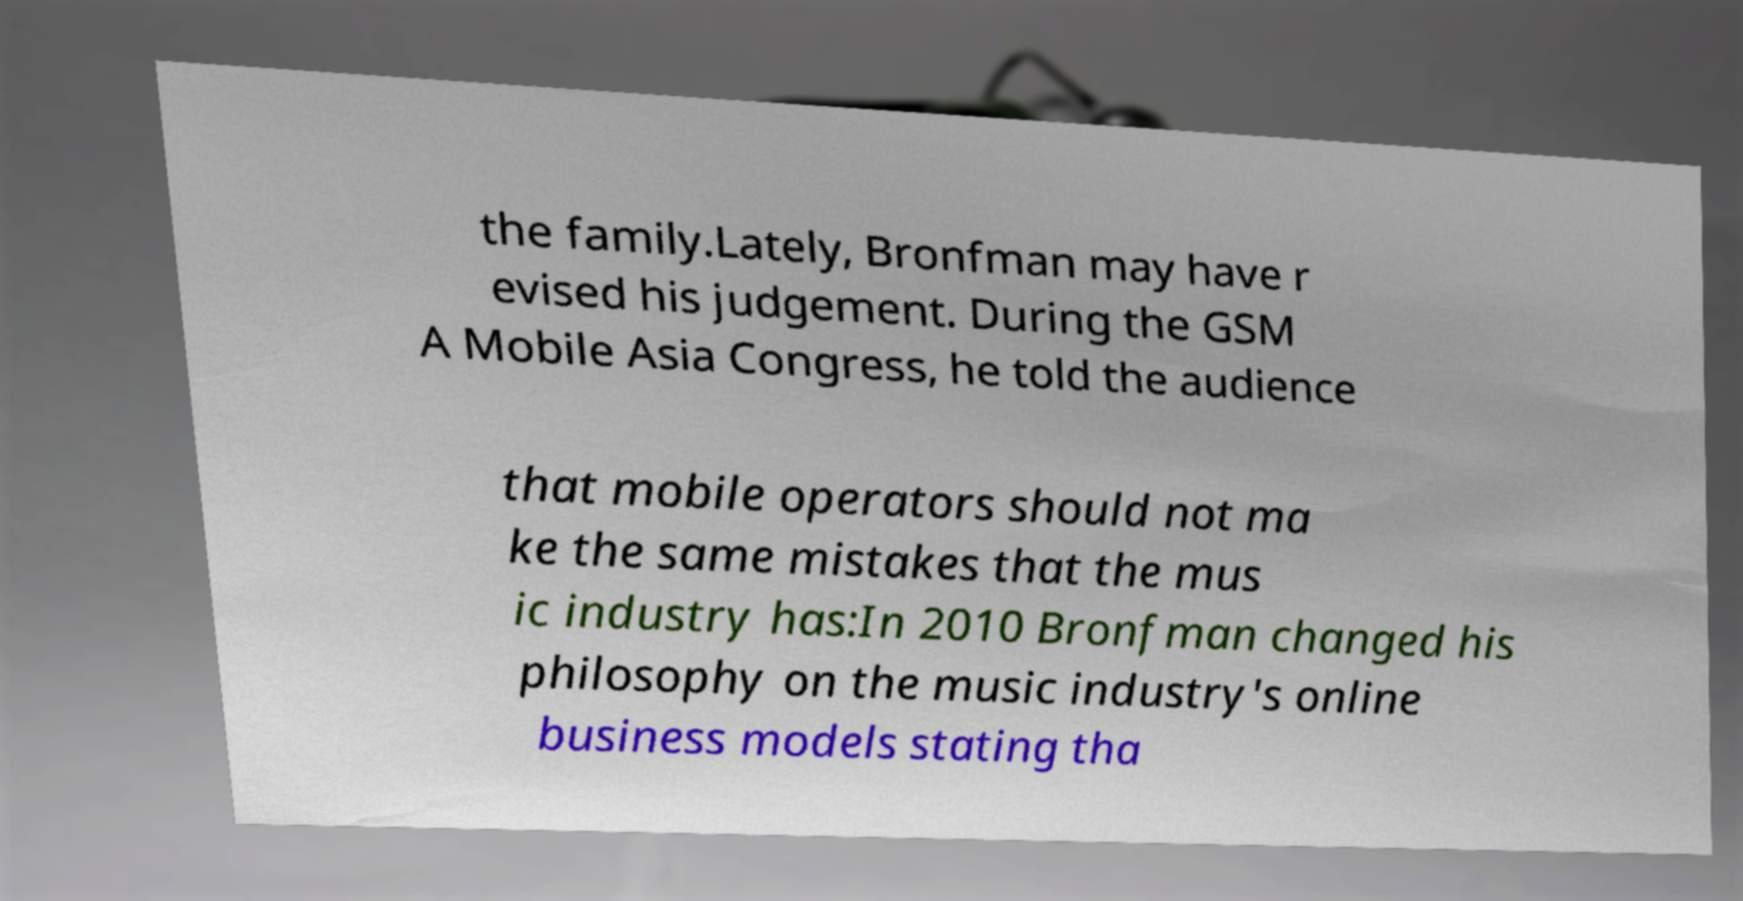I need the written content from this picture converted into text. Can you do that? the family.Lately, Bronfman may have r evised his judgement. During the GSM A Mobile Asia Congress, he told the audience that mobile operators should not ma ke the same mistakes that the mus ic industry has:In 2010 Bronfman changed his philosophy on the music industry's online business models stating tha 